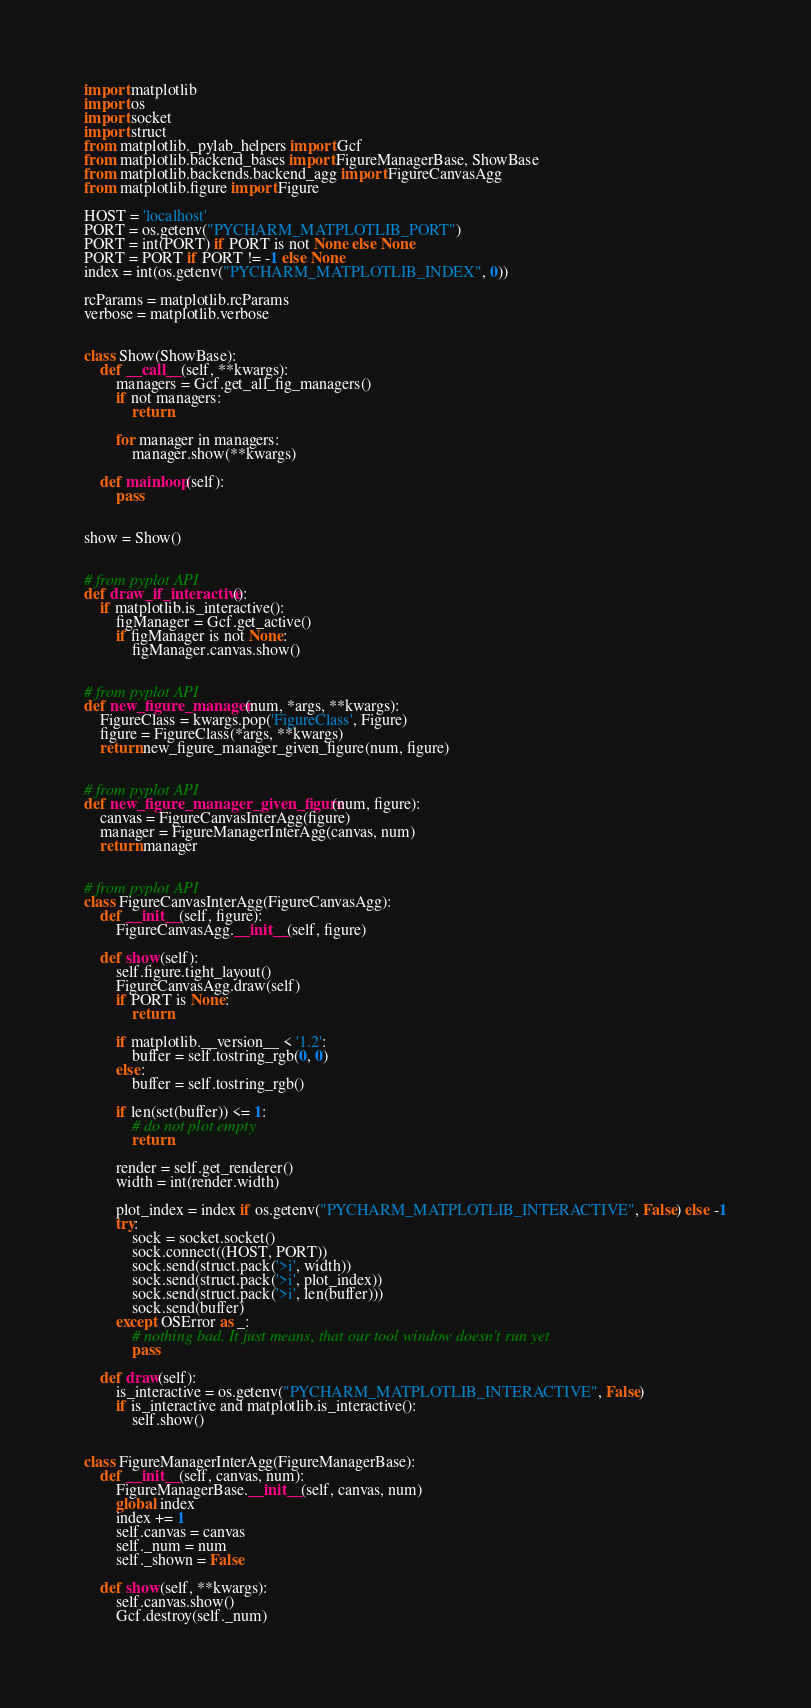Convert code to text. <code><loc_0><loc_0><loc_500><loc_500><_Python_>import matplotlib
import os
import socket
import struct
from matplotlib._pylab_helpers import Gcf
from matplotlib.backend_bases import FigureManagerBase, ShowBase
from matplotlib.backends.backend_agg import FigureCanvasAgg
from matplotlib.figure import Figure

HOST = 'localhost'
PORT = os.getenv("PYCHARM_MATPLOTLIB_PORT")
PORT = int(PORT) if PORT is not None else None
PORT = PORT if PORT != -1 else None
index = int(os.getenv("PYCHARM_MATPLOTLIB_INDEX", 0))

rcParams = matplotlib.rcParams
verbose = matplotlib.verbose


class Show(ShowBase):
    def __call__(self, **kwargs):
        managers = Gcf.get_all_fig_managers()
        if not managers:
            return

        for manager in managers:
            manager.show(**kwargs)

    def mainloop(self):
        pass


show = Show()


# from pyplot API
def draw_if_interactive():
    if matplotlib.is_interactive():
        figManager = Gcf.get_active()
        if figManager is not None:
            figManager.canvas.show()


# from pyplot API
def new_figure_manager(num, *args, **kwargs):
    FigureClass = kwargs.pop('FigureClass', Figure)
    figure = FigureClass(*args, **kwargs)
    return new_figure_manager_given_figure(num, figure)


# from pyplot API
def new_figure_manager_given_figure(num, figure):
    canvas = FigureCanvasInterAgg(figure)
    manager = FigureManagerInterAgg(canvas, num)
    return manager


# from pyplot API
class FigureCanvasInterAgg(FigureCanvasAgg):
    def __init__(self, figure):
        FigureCanvasAgg.__init__(self, figure)

    def show(self):
        self.figure.tight_layout()
        FigureCanvasAgg.draw(self)
        if PORT is None:
            return

        if matplotlib.__version__ < '1.2':
            buffer = self.tostring_rgb(0, 0)
        else:
            buffer = self.tostring_rgb()

        if len(set(buffer)) <= 1:
            # do not plot empty
            return

        render = self.get_renderer()
        width = int(render.width)

        plot_index = index if os.getenv("PYCHARM_MATPLOTLIB_INTERACTIVE", False) else -1
        try:
            sock = socket.socket()
            sock.connect((HOST, PORT))
            sock.send(struct.pack('>i', width))
            sock.send(struct.pack('>i', plot_index))
            sock.send(struct.pack('>i', len(buffer)))
            sock.send(buffer)
        except OSError as _:
            # nothing bad. It just means, that our tool window doesn't run yet
            pass

    def draw(self):
        is_interactive = os.getenv("PYCHARM_MATPLOTLIB_INTERACTIVE", False)
        if is_interactive and matplotlib.is_interactive():
            self.show()


class FigureManagerInterAgg(FigureManagerBase):
    def __init__(self, canvas, num):
        FigureManagerBase.__init__(self, canvas, num)
        global index
        index += 1
        self.canvas = canvas
        self._num = num
        self._shown = False

    def show(self, **kwargs):
        self.canvas.show()
        Gcf.destroy(self._num)
</code> 